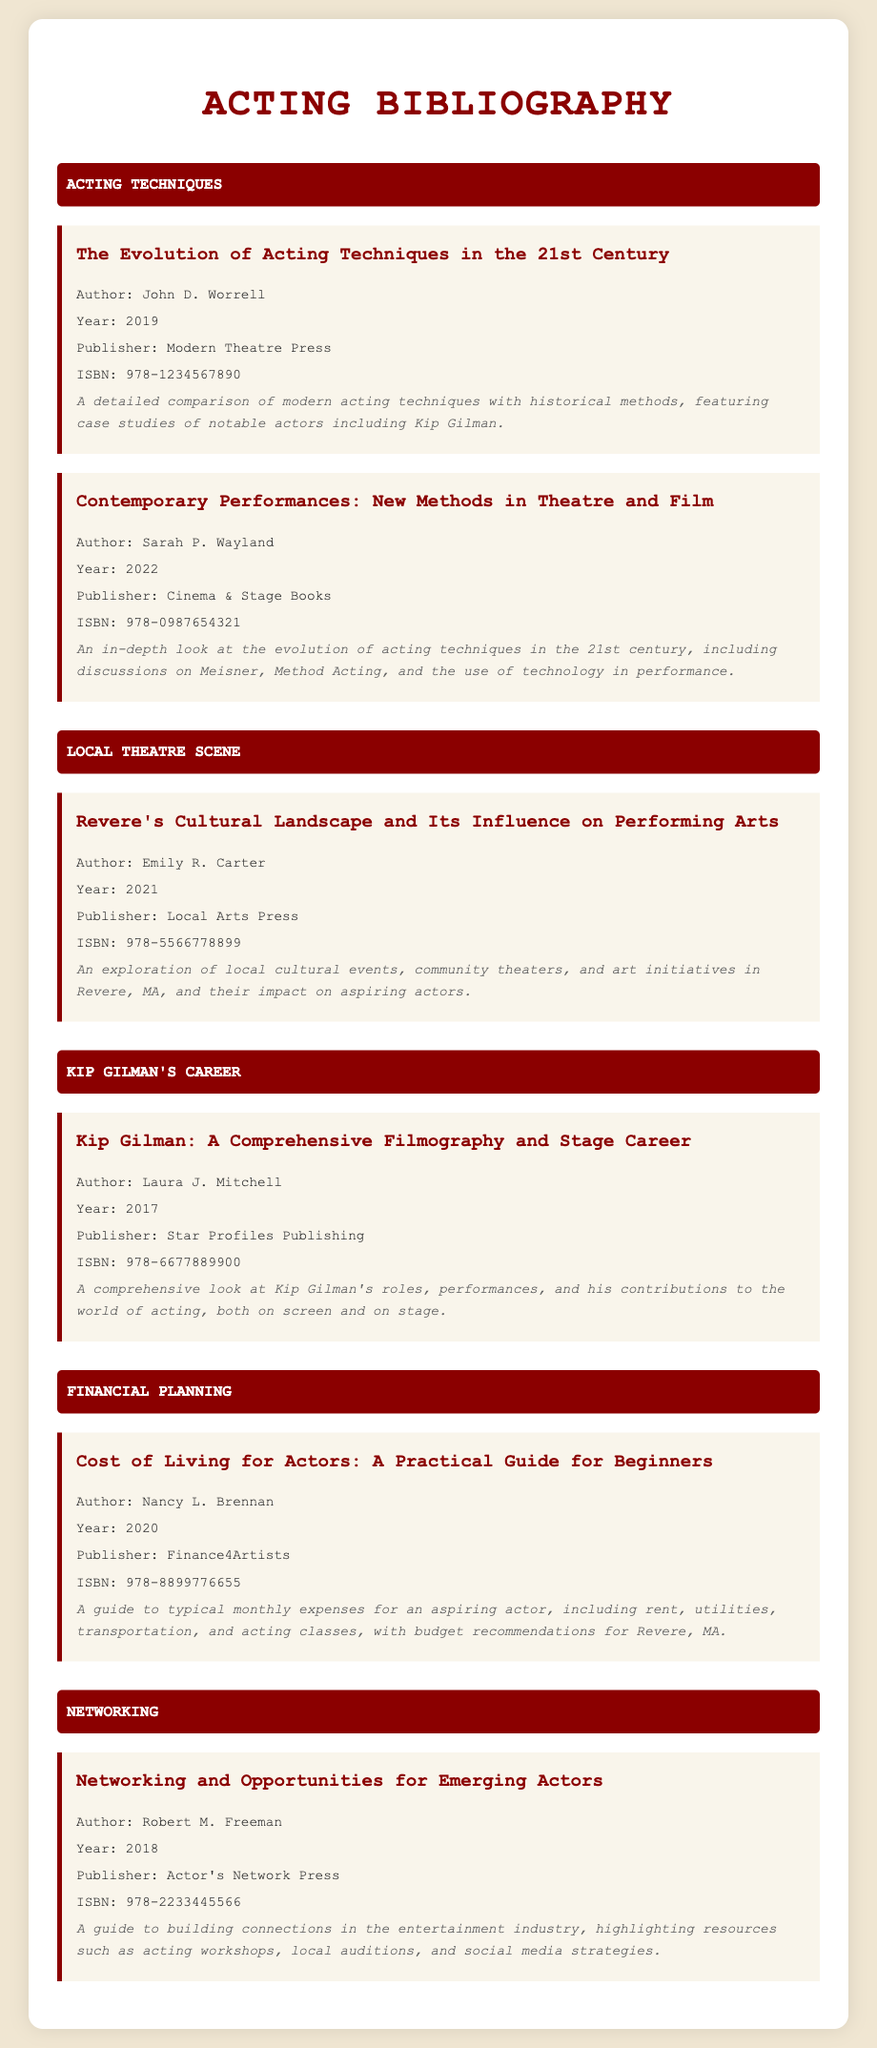what is the title of the first item? The title of the first item in the bibliography is "The Evolution of Acting Techniques in the 21st Century."
Answer: The Evolution of Acting Techniques in the 21st Century who is the author of the book about Kip Gilman's career? The author of the book titled "Kip Gilman: A Comprehensive Filmography and Stage Career" is Laura J. Mitchell.
Answer: Laura J. Mitchell what year was the book on networking published? The book "Networking and Opportunities for Emerging Actors" was published in 2018.
Answer: 2018 which publisher released the book on living expenses for actors? The publisher of "Cost of Living for Actors: A Practical Guide for Beginners" is Finance4Artists.
Answer: Finance4Artists how many books are listed under the section "Local Theatre Scene"? There is one book listed under the section "Local Theatre Scene."
Answer: 1 what is the ISBN of the book written by John D. Worrell? The ISBN of "The Evolution of Acting Techniques in the 21st Century" is 978-1234567890.
Answer: 978-1234567890 which category includes a book written by Emily R. Carter? The category that includes a book written by Emily R. Carter is "Local Theatre Scene."
Answer: Local Theatre Scene what is the main topic of the book by Nancy L. Brennan? The main topic of the book by Nancy L. Brennan is the monthly expenses for an aspiring actor.
Answer: Monthly expenses for an aspiring actor who authored the book that discusses contemporary performances? The author of the book "Contemporary Performances: New Methods in Theatre and Film" is Sarah P. Wayland.
Answer: Sarah P. Wayland 